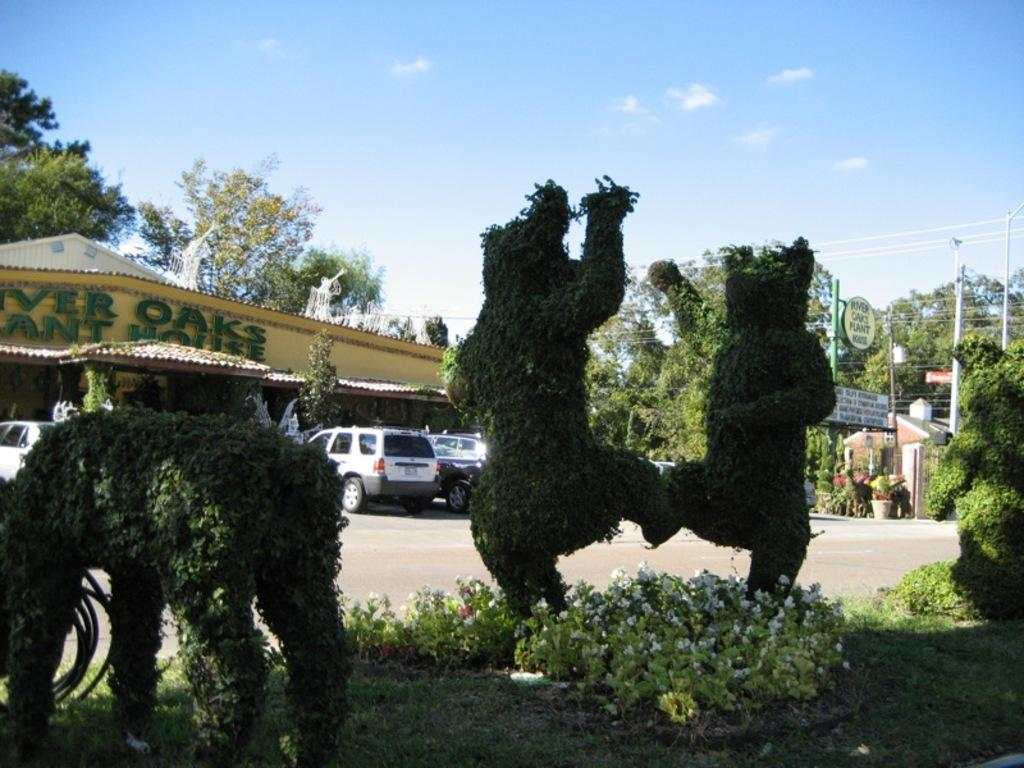What type of vegetation can be seen in the image? There are plants in different structures in the image. What is located beside the plants? There is a road beside the plants. What can be seen in the background of the image? Cars, shops, trees, and the sky are visible in the background. What type of joke is being told by the cats in the image? There are no cats present in the image, so it is not possible to determine if a joke is being told. 